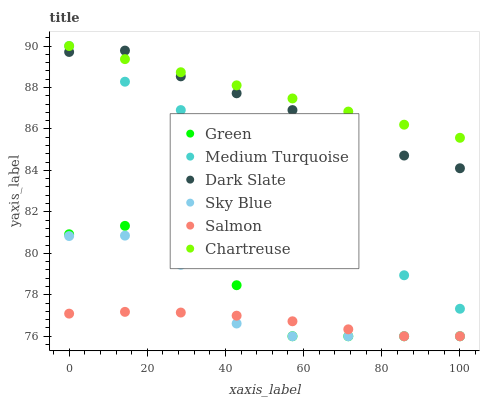Does Salmon have the minimum area under the curve?
Answer yes or no. Yes. Does Chartreuse have the maximum area under the curve?
Answer yes or no. Yes. Does Dark Slate have the minimum area under the curve?
Answer yes or no. No. Does Dark Slate have the maximum area under the curve?
Answer yes or no. No. Is Chartreuse the smoothest?
Answer yes or no. Yes. Is Sky Blue the roughest?
Answer yes or no. Yes. Is Dark Slate the smoothest?
Answer yes or no. No. Is Dark Slate the roughest?
Answer yes or no. No. Does Salmon have the lowest value?
Answer yes or no. Yes. Does Dark Slate have the lowest value?
Answer yes or no. No. Does Medium Turquoise have the highest value?
Answer yes or no. Yes. Does Dark Slate have the highest value?
Answer yes or no. No. Is Sky Blue less than Medium Turquoise?
Answer yes or no. Yes. Is Dark Slate greater than Salmon?
Answer yes or no. Yes. Does Medium Turquoise intersect Chartreuse?
Answer yes or no. Yes. Is Medium Turquoise less than Chartreuse?
Answer yes or no. No. Is Medium Turquoise greater than Chartreuse?
Answer yes or no. No. Does Sky Blue intersect Medium Turquoise?
Answer yes or no. No. 